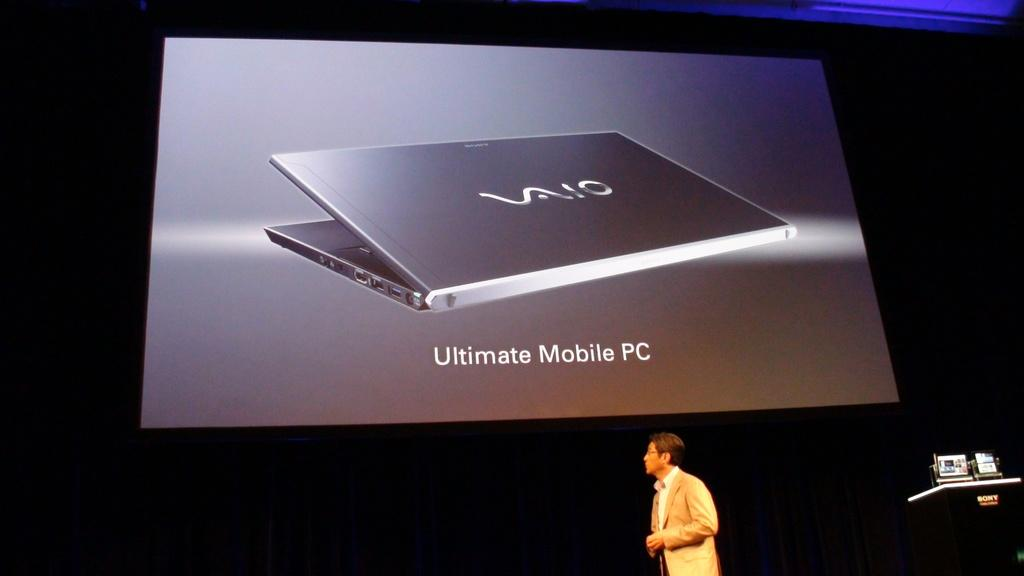What is the main object in the center of the image? There is a screen in the center of the image. What is being displayed on the screen? A laptop is visible on the screen. Who is present in the image? A man is standing at the bottom of the image. What object is located in the bottom right corner of the image? There is a podium in the bottom right corner of the image. What type of straw is being used by the man in the image? There is no straw present in the image; the man is not holding or using any straw. 